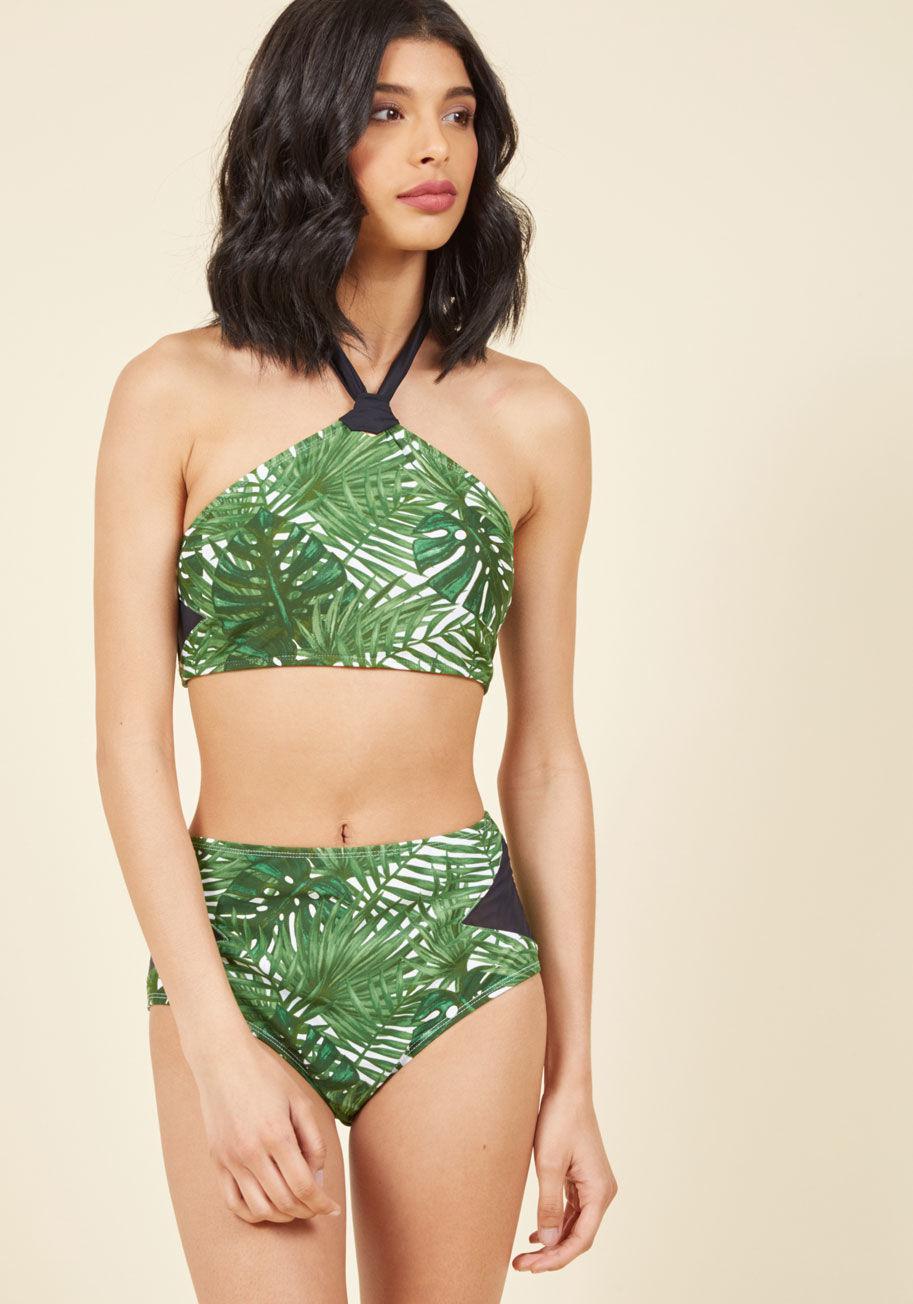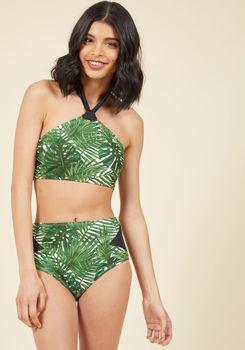The first image is the image on the left, the second image is the image on the right. Evaluate the accuracy of this statement regarding the images: "At least one image shows a model wearing a high-waisted bikini bottom that just reaches the navel.". Is it true? Answer yes or no. Yes. The first image is the image on the left, the second image is the image on the right. For the images shown, is this caption "There is one red bikini" true? Answer yes or no. No. 